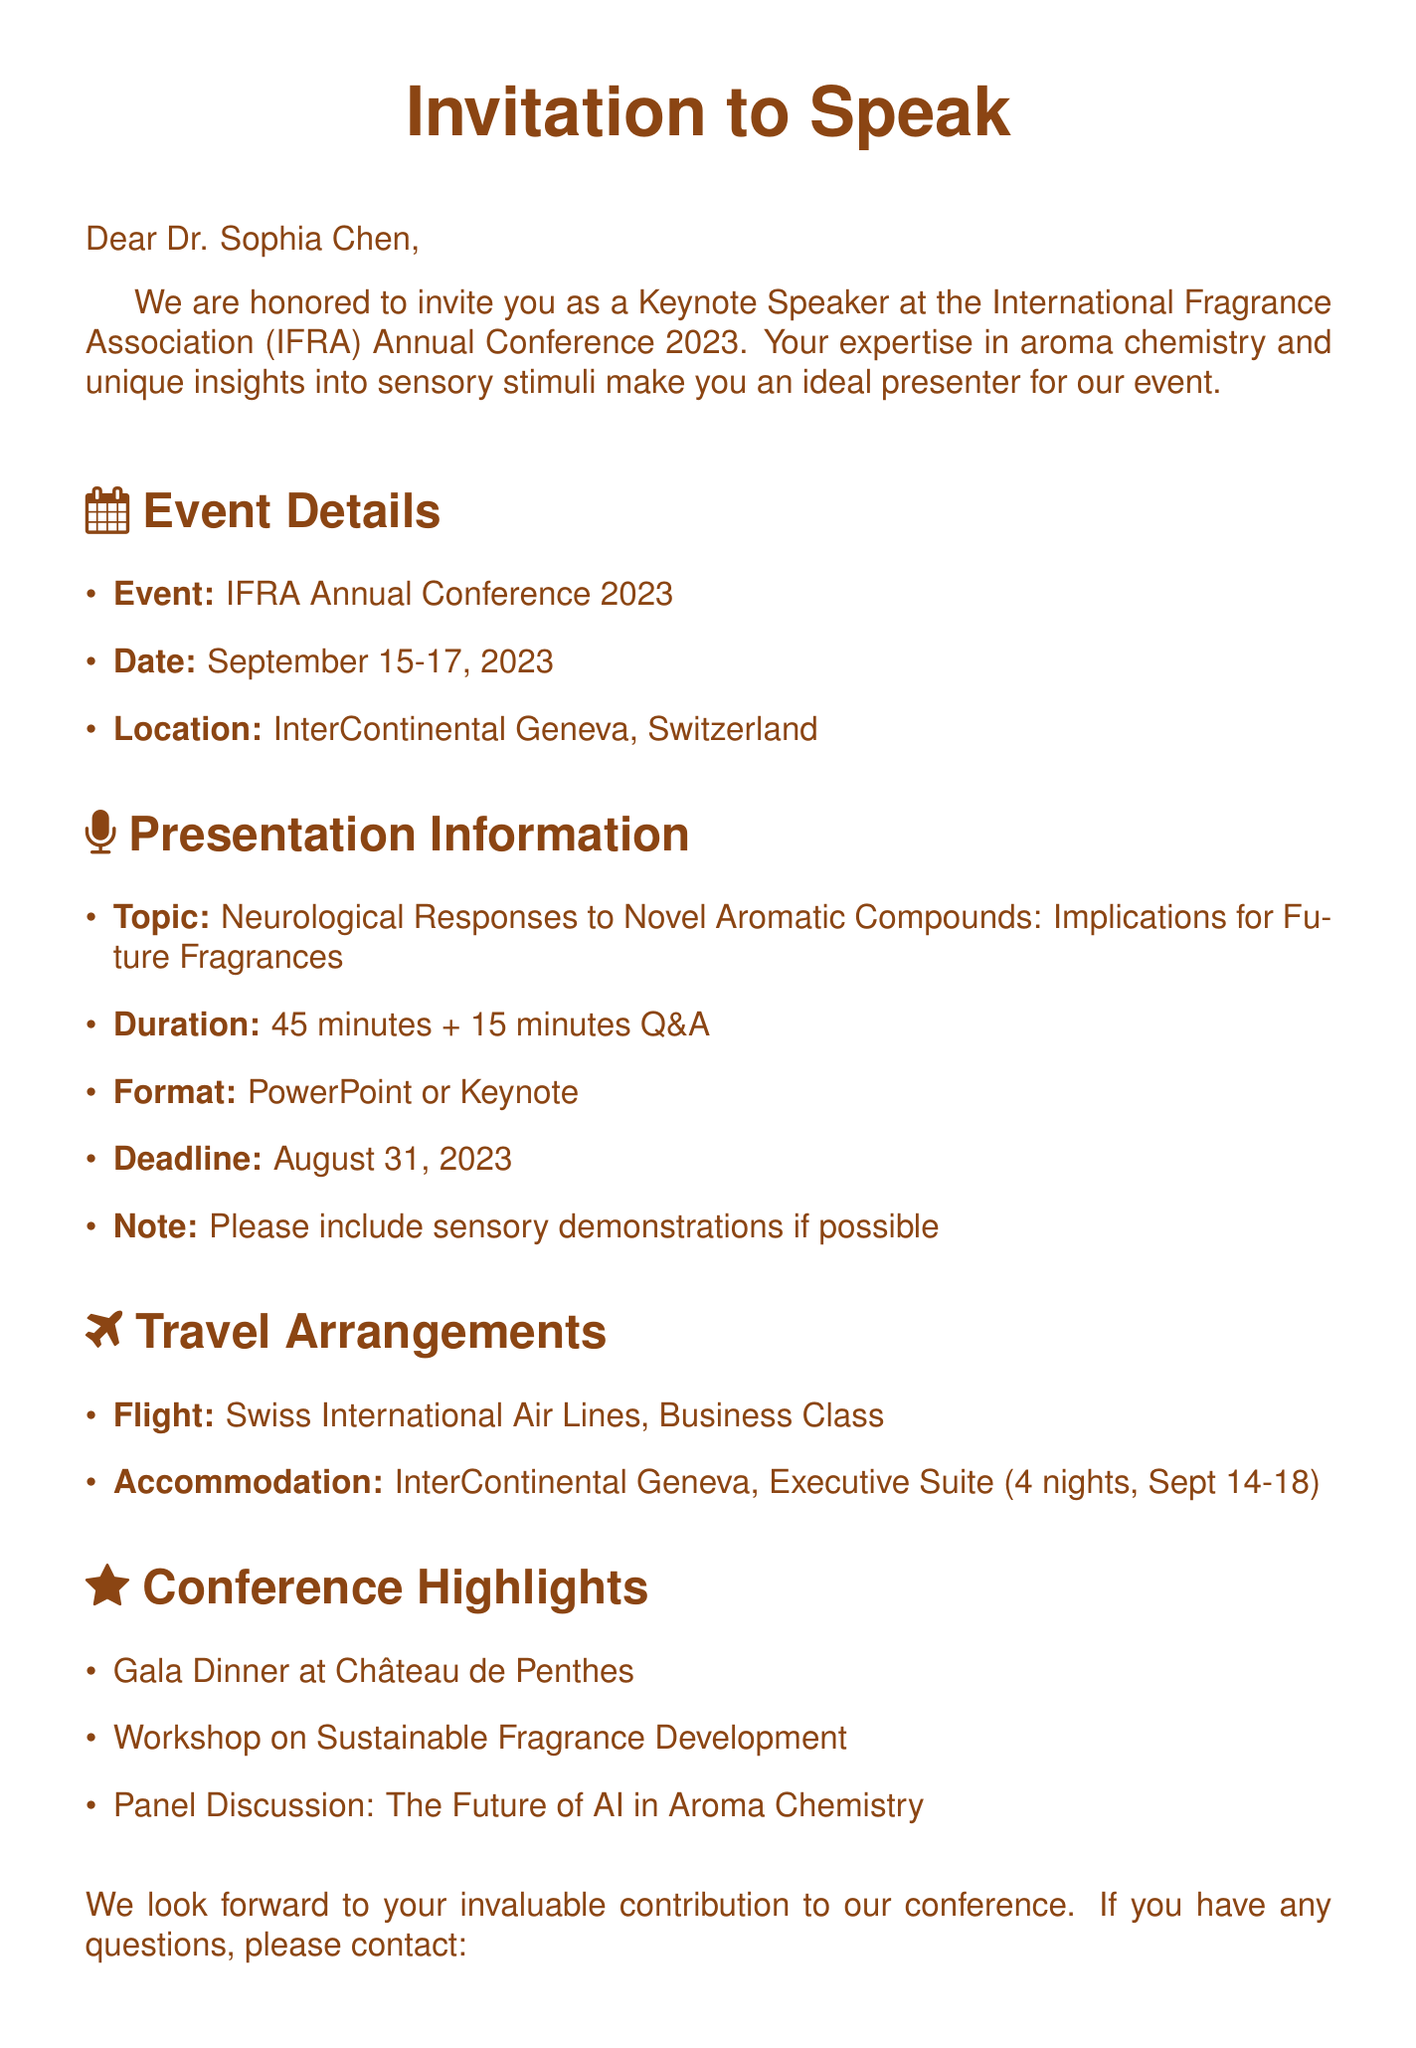What are the dates of the conference? The dates of the conference are specified in the event details section of the document.
Answer: September 15-17, 2023 Who is the contact person for the conference? The contact person is mentioned in the final section of the document, including their name and position.
Answer: Dr. Martina Bianchi What is the topic of the keynote presentation? The topic is clearly stated in the presentation information section of the document.
Answer: Neurological Responses to Novel Aromatic Compounds: Implications for Future Fragrances How long is the presentation? The presentation duration is indicated in the presentation information section of the document.
Answer: 45 minutes + 15 minutes Q&A What is the deadline for submission of presentation materials? The submission deadline is specified in the presentation guidelines within the document.
Answer: August 31, 2023 What type of accommodations are provided? The document details the type of accommodation included in the travel arrangements section.
Answer: Executive Suite What airline is providing the flight? The airline is mentioned in the travel arrangements section of the document.
Answer: Swiss International Air Lines What special event is highlighted in the conference? The special event is indicated under the conference highlights section of the document.
Answer: Gala Dinner at Château de Penthes What format should the presentation be in? The required presentation format is listed in the presentation information section of the document.
Answer: PowerPoint or Keynote 